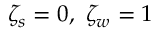<formula> <loc_0><loc_0><loc_500><loc_500>\zeta _ { s } = 0 , \ \zeta _ { w } = 1</formula> 